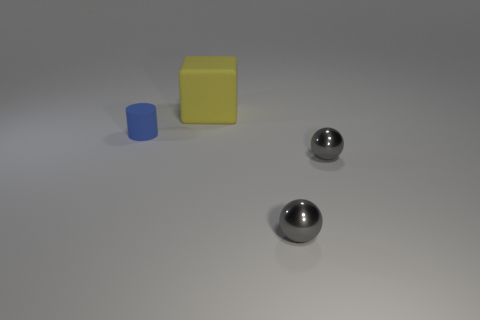Add 2 big cyan blocks. How many objects exist? 6 Subtract all cylinders. How many objects are left? 3 Subtract all brown spheres. Subtract all cyan cubes. How many spheres are left? 2 Subtract all blue cylinders. Subtract all gray metallic balls. How many objects are left? 1 Add 2 gray objects. How many gray objects are left? 4 Add 2 large green matte blocks. How many large green matte blocks exist? 2 Subtract 0 blue spheres. How many objects are left? 4 